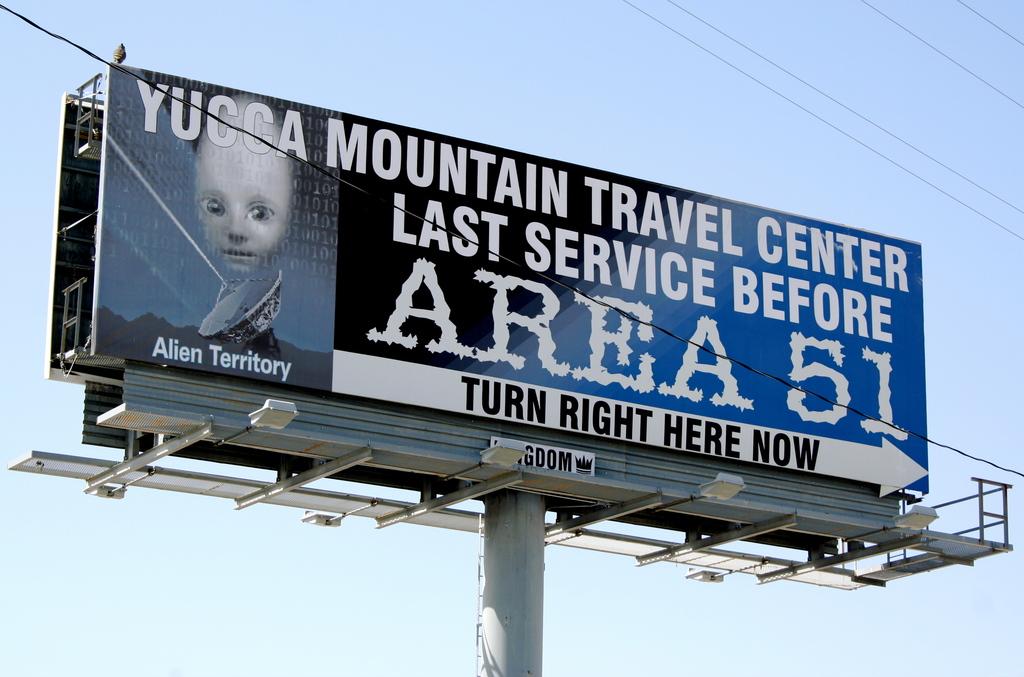Who's territory is it?
Provide a short and direct response. Alien. 